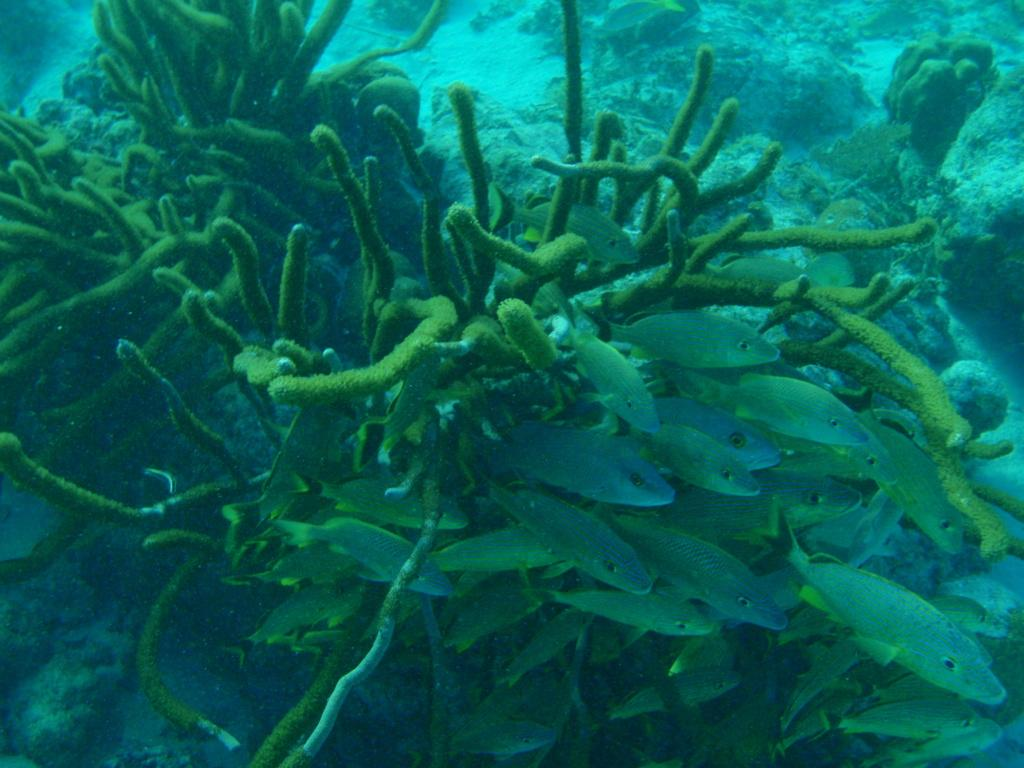What type of animals can be seen in the water in the image? There are fishes in the water in the image. What else can be seen in the water besides the fishes? There are plants in the water in the image. How does the cart help the fishes move around in the image? There is no cart present in the image, and therefore it cannot help the fishes move around. 